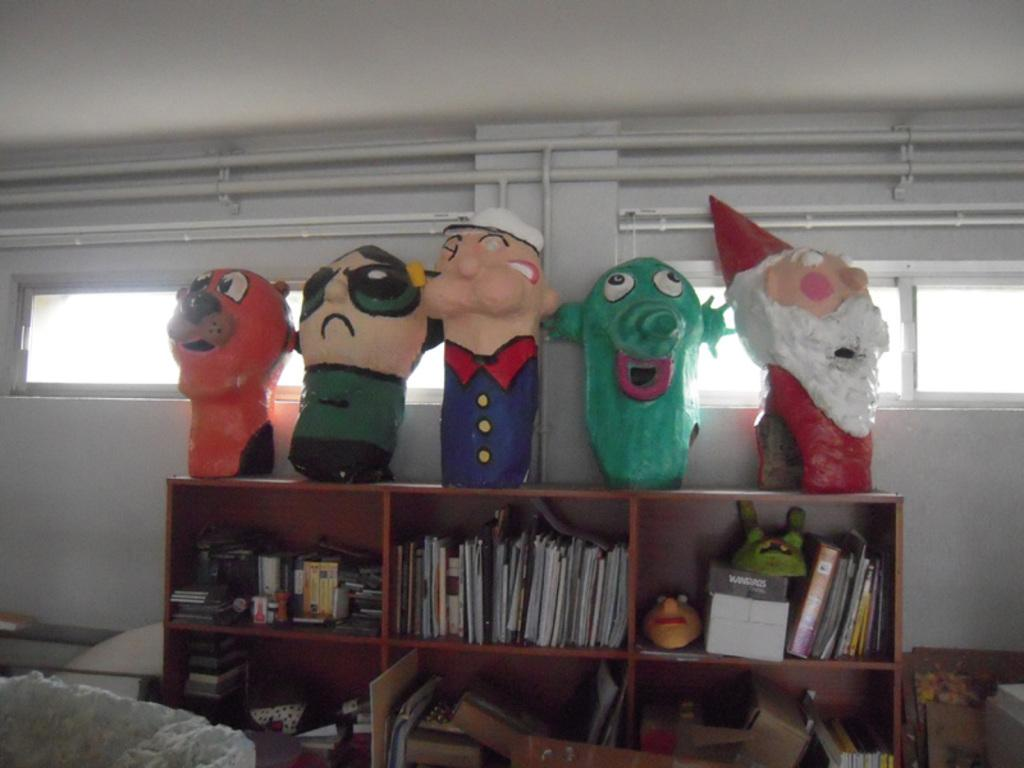What type of furniture is present in the image? There is a cupboard in the image. What items can be found inside the cupboard? The cupboard contains books, masks, and other items. What is placed on top of the cupboard? There are toys on top of the cupboard. What can be seen in the background of the image? There is a wall with pipes and windows in the background. What type of produce is hanging from the ceiling in the image? There is no produce hanging from the ceiling in the image. How many things are hanging from the ceiling in the image? There are no things hanging from the ceiling in the image. 